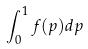Convert formula to latex. <formula><loc_0><loc_0><loc_500><loc_500>\int _ { 0 } ^ { 1 } f ( p ) d p</formula> 